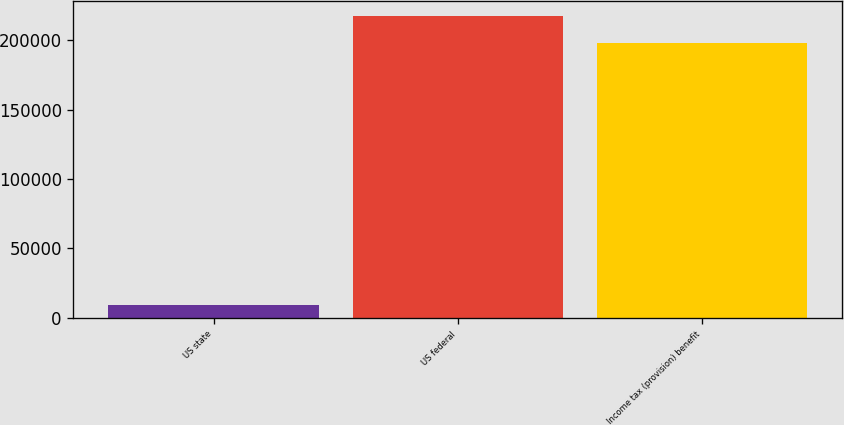<chart> <loc_0><loc_0><loc_500><loc_500><bar_chart><fcel>US state<fcel>US federal<fcel>Income tax (provision) benefit<nl><fcel>9065<fcel>217452<fcel>197644<nl></chart> 